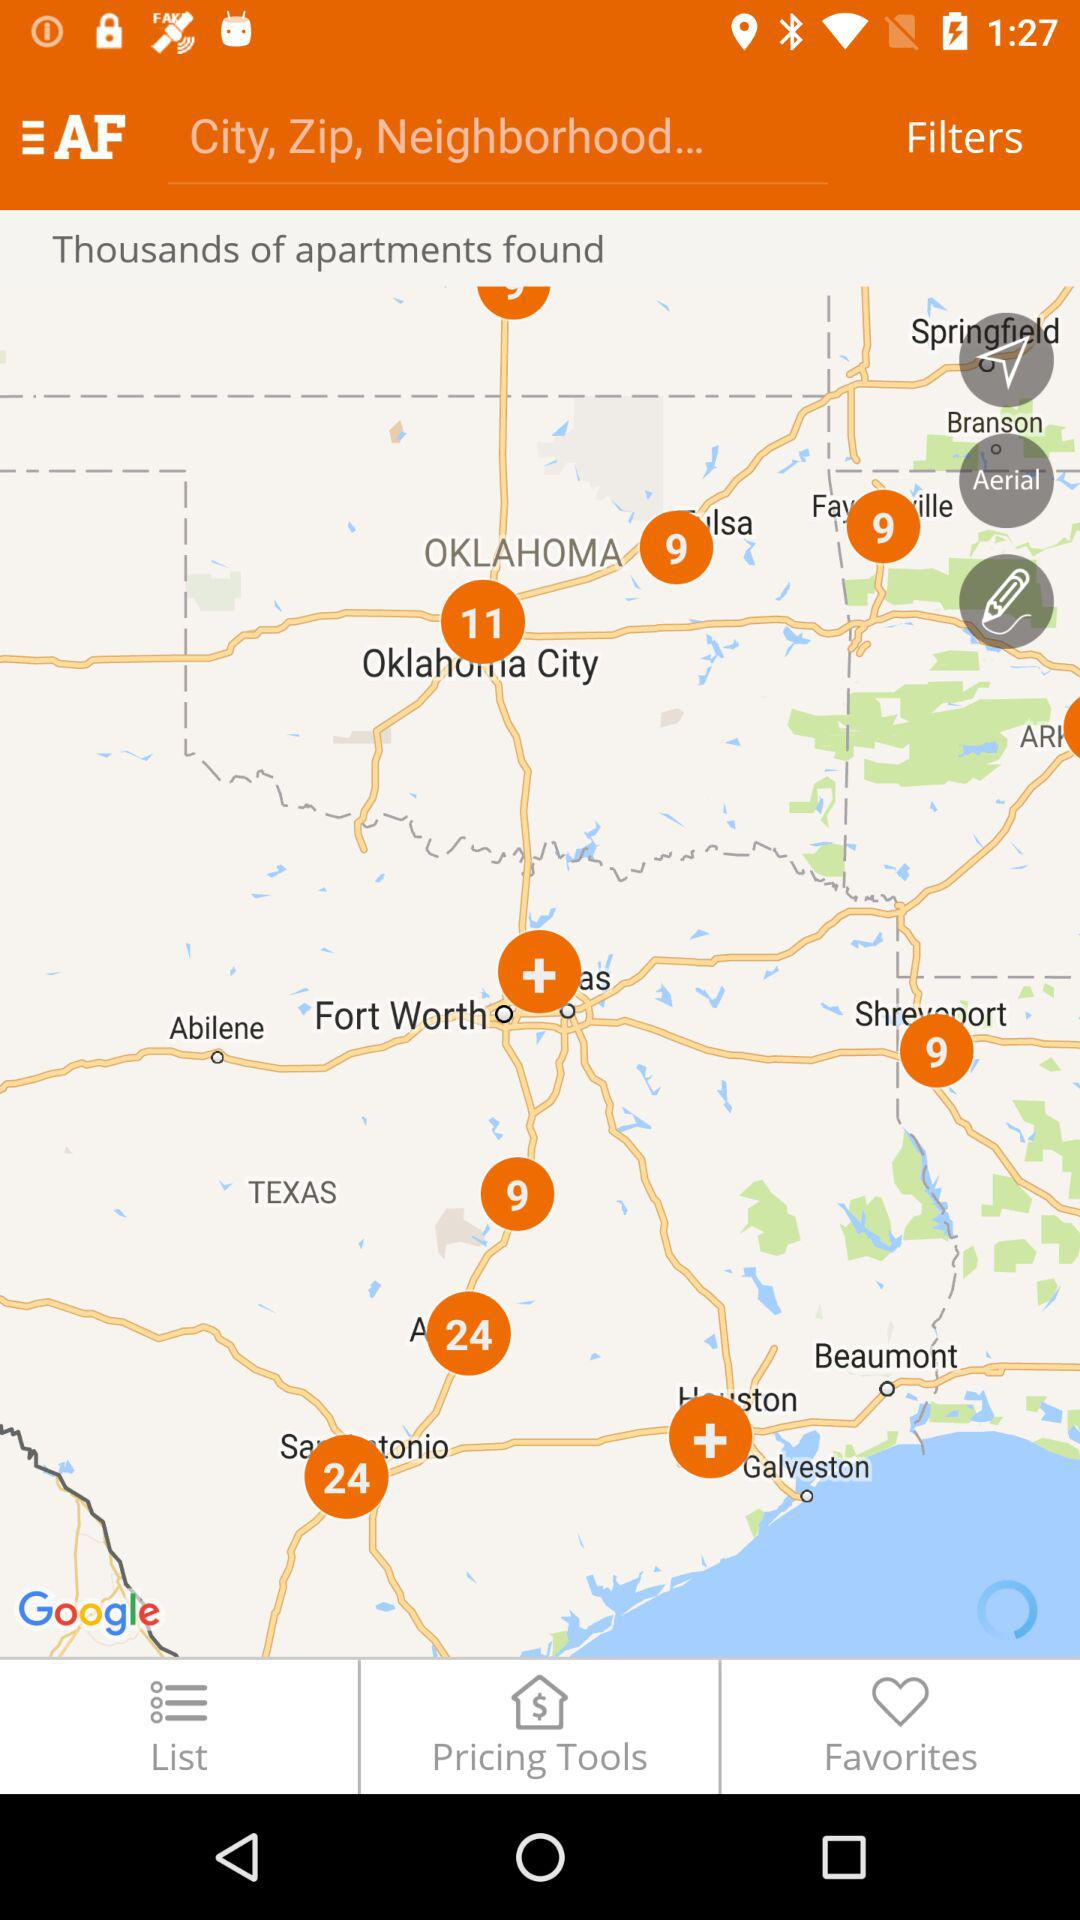How many apartments are found? There are thousands of apartments found. 